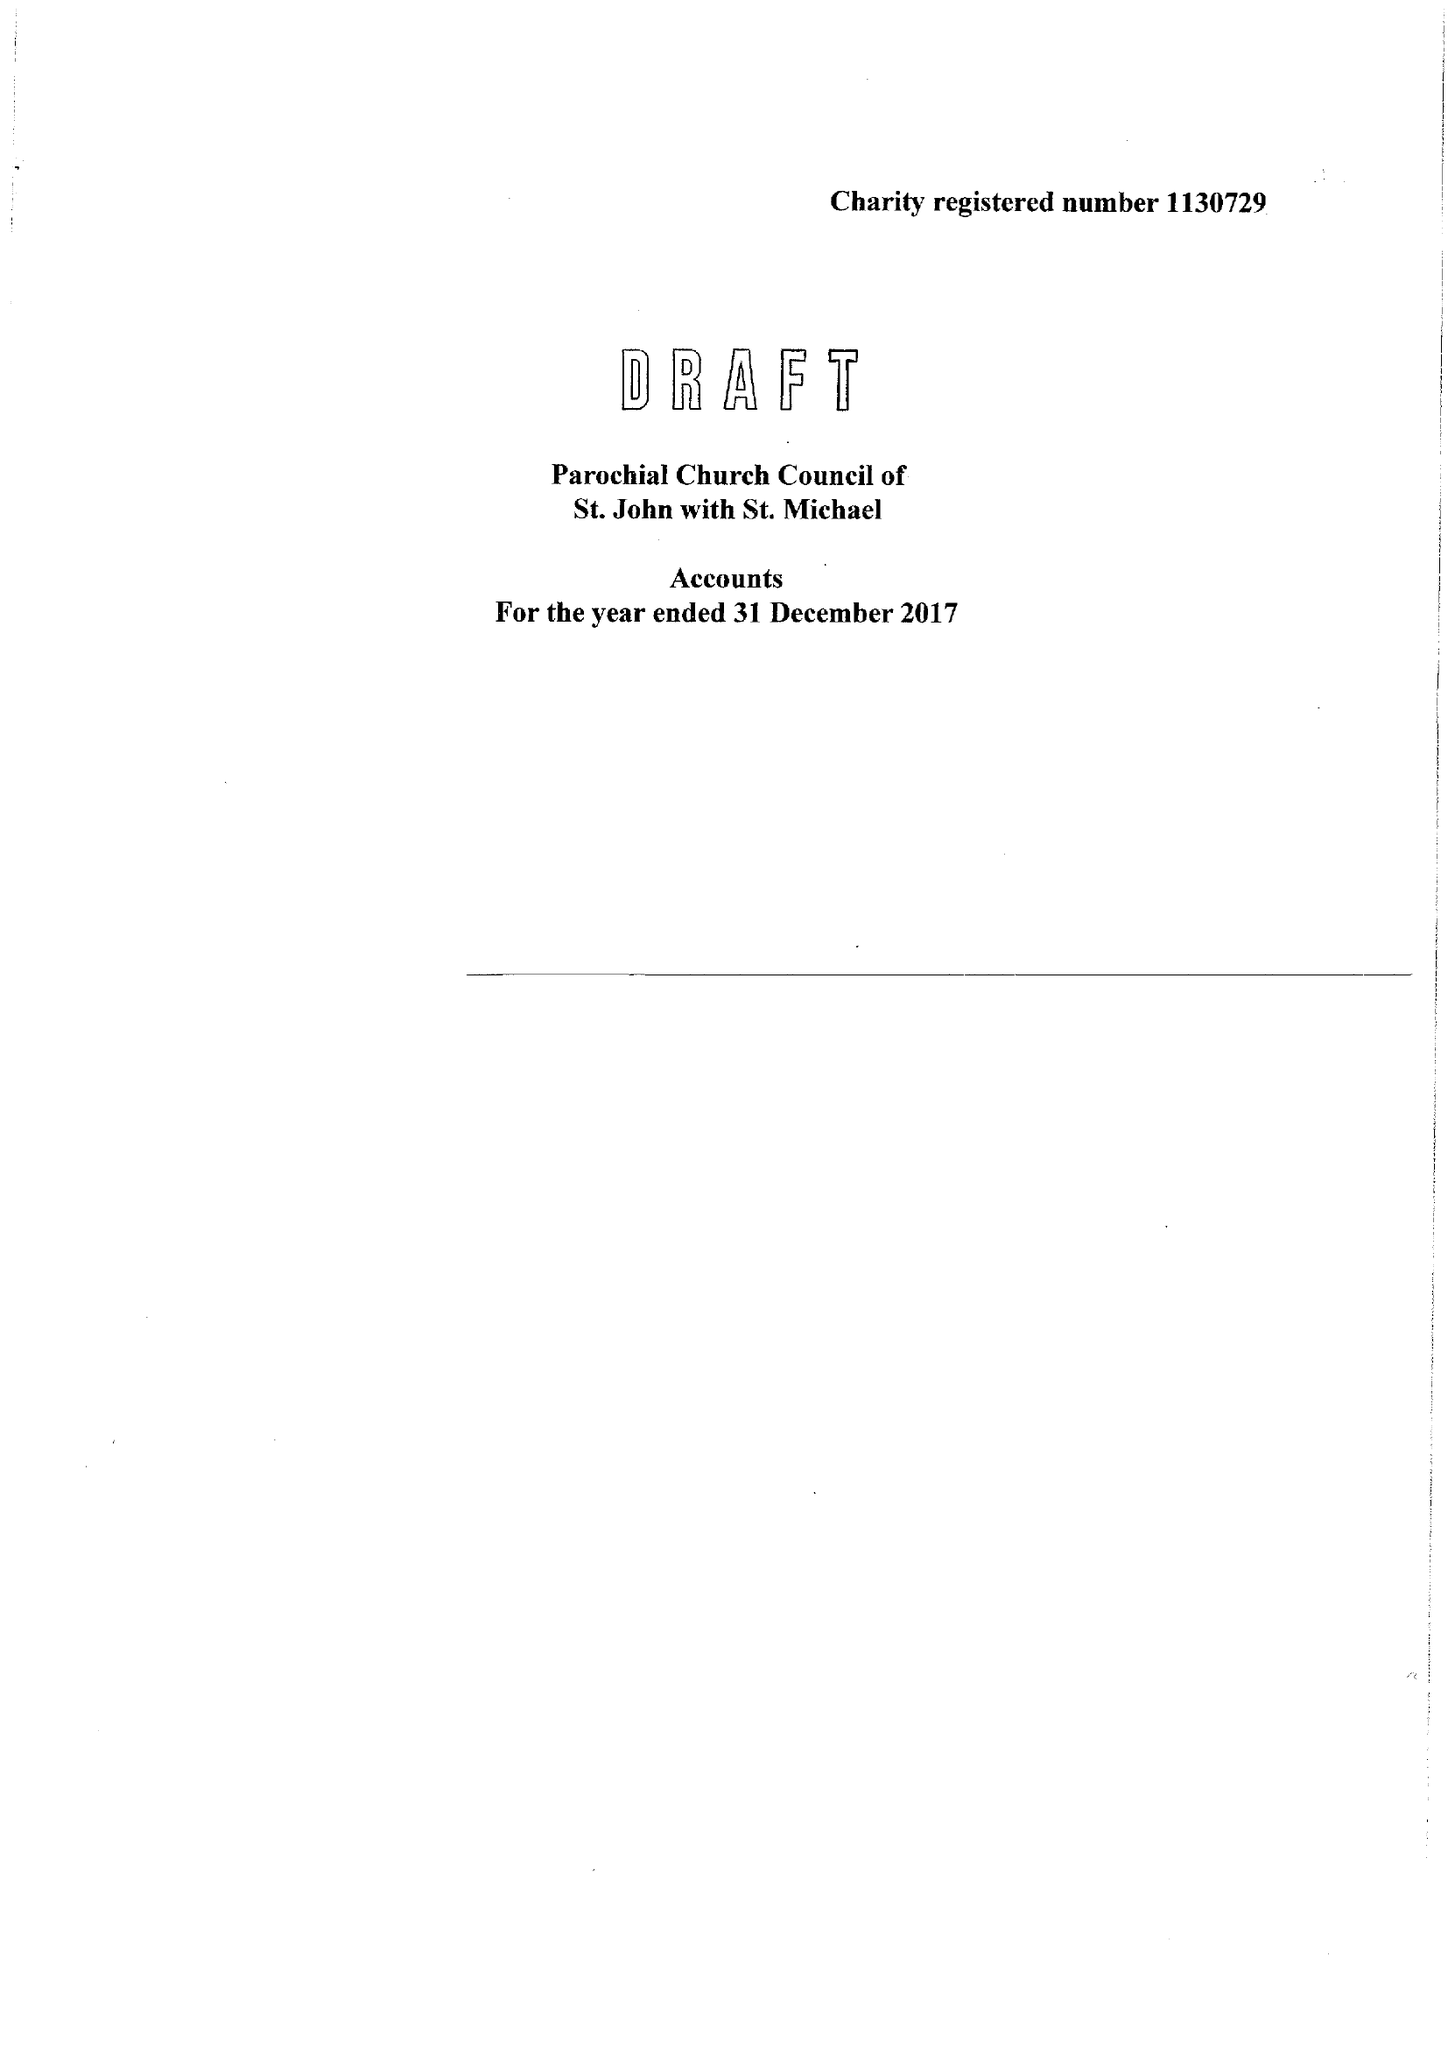What is the value for the address__street_line?
Answer the question using a single word or phrase. None 